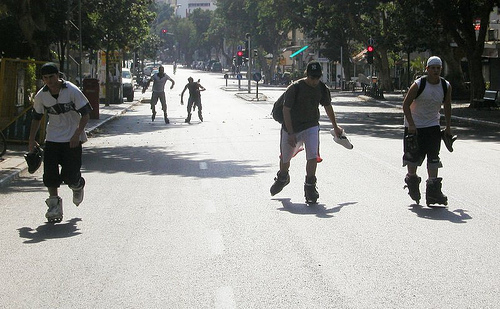What enables these people to go faster on the street?
A. ice skates
B. skate boards
C. roller skates
D. roller blades
Answer with the option's letter from the given choices directly. D 